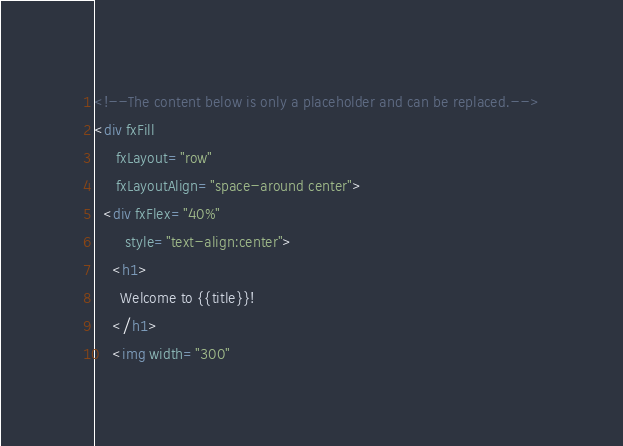Convert code to text. <code><loc_0><loc_0><loc_500><loc_500><_HTML_><!--The content below is only a placeholder and can be replaced.-->
<div fxFill
     fxLayout="row"
     fxLayoutAlign="space-around center">
  <div fxFlex="40%"
       style="text-align:center">
    <h1>
      Welcome to {{title}}!
    </h1>
    <img width="300"</code> 